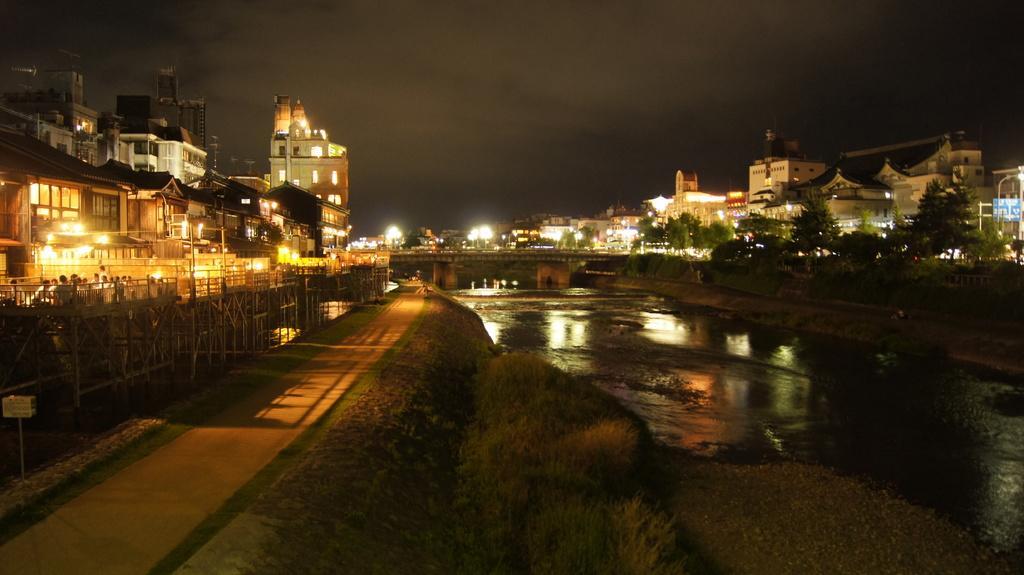Could you give a brief overview of what you see in this image? On the left side of the image there is a road. Beside the road there's grass on the ground. And also there is water. Above the water there is a bridge with pillars. Behind the road on the left side there is railing with wooden poles. And also there are few people. In the image there are buildings with lights. At the top of the image there is sky. 